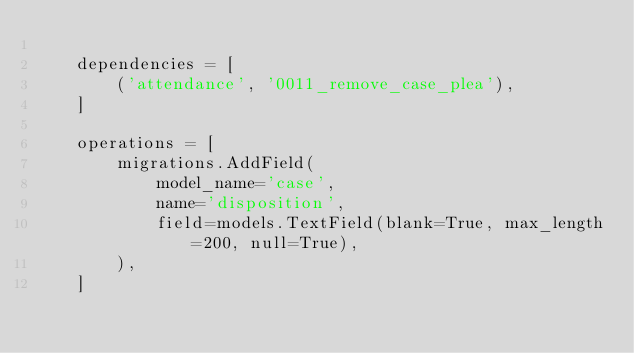Convert code to text. <code><loc_0><loc_0><loc_500><loc_500><_Python_>
    dependencies = [
        ('attendance', '0011_remove_case_plea'),
    ]

    operations = [
        migrations.AddField(
            model_name='case',
            name='disposition',
            field=models.TextField(blank=True, max_length=200, null=True),
        ),
    ]
</code> 